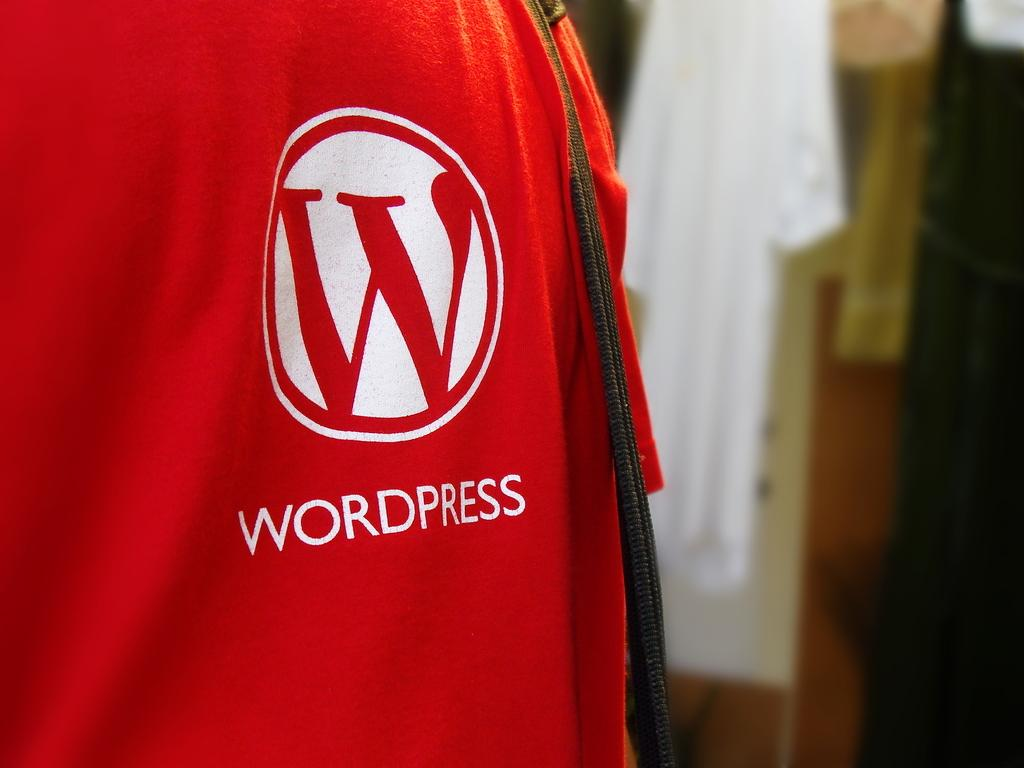What colors are used for the cloth in the image? The cloth in the image is red and white colored. How would you describe the background of the image? The background of the image is blurry. What other cloth can be seen in the background? There is a white colored cloth visible in the background. Can you describe any other objects present in the background? There are other objects present in the background, but their details are not clear due to the blurry background. How many pancakes are stacked on the stem in the image? There are no pancakes or stems present in the image. What type of mice can be seen playing with the cloth in the image? There are no mice present in the image; it only features a red and white colored cloth and a blurry background. 